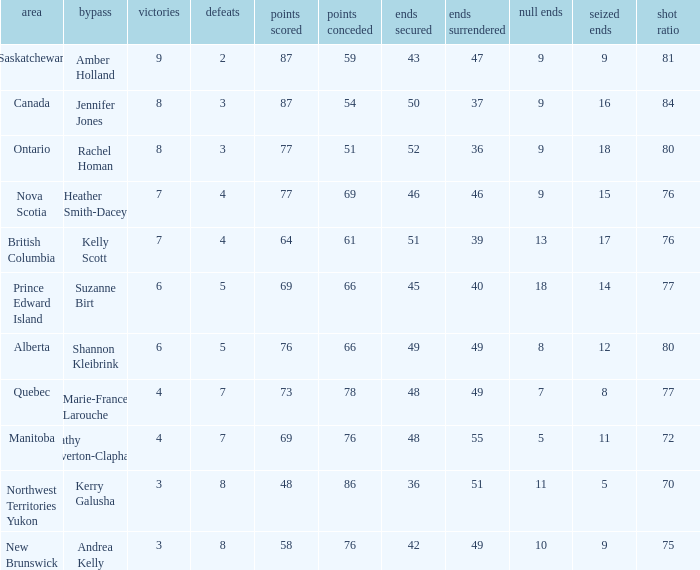If the locale is Ontario, what is the W minimum? 8.0. Can you parse all the data within this table? {'header': ['area', 'bypass', 'victories', 'defeats', 'points scored', 'points conceded', 'ends secured', 'ends surrendered', 'null ends', 'seized ends', 'shot ratio'], 'rows': [['Saskatchewan', 'Amber Holland', '9', '2', '87', '59', '43', '47', '9', '9', '81'], ['Canada', 'Jennifer Jones', '8', '3', '87', '54', '50', '37', '9', '16', '84'], ['Ontario', 'Rachel Homan', '8', '3', '77', '51', '52', '36', '9', '18', '80'], ['Nova Scotia', 'Heather Smith-Dacey', '7', '4', '77', '69', '46', '46', '9', '15', '76'], ['British Columbia', 'Kelly Scott', '7', '4', '64', '61', '51', '39', '13', '17', '76'], ['Prince Edward Island', 'Suzanne Birt', '6', '5', '69', '66', '45', '40', '18', '14', '77'], ['Alberta', 'Shannon Kleibrink', '6', '5', '76', '66', '49', '49', '8', '12', '80'], ['Quebec', 'Marie-France Larouche', '4', '7', '73', '78', '48', '49', '7', '8', '77'], ['Manitoba', 'Cathy Overton-Clapham', '4', '7', '69', '76', '48', '55', '5', '11', '72'], ['Northwest Territories Yukon', 'Kerry Galusha', '3', '8', '48', '86', '36', '51', '11', '5', '70'], ['New Brunswick', 'Andrea Kelly', '3', '8', '58', '76', '42', '49', '10', '9', '75']]} 